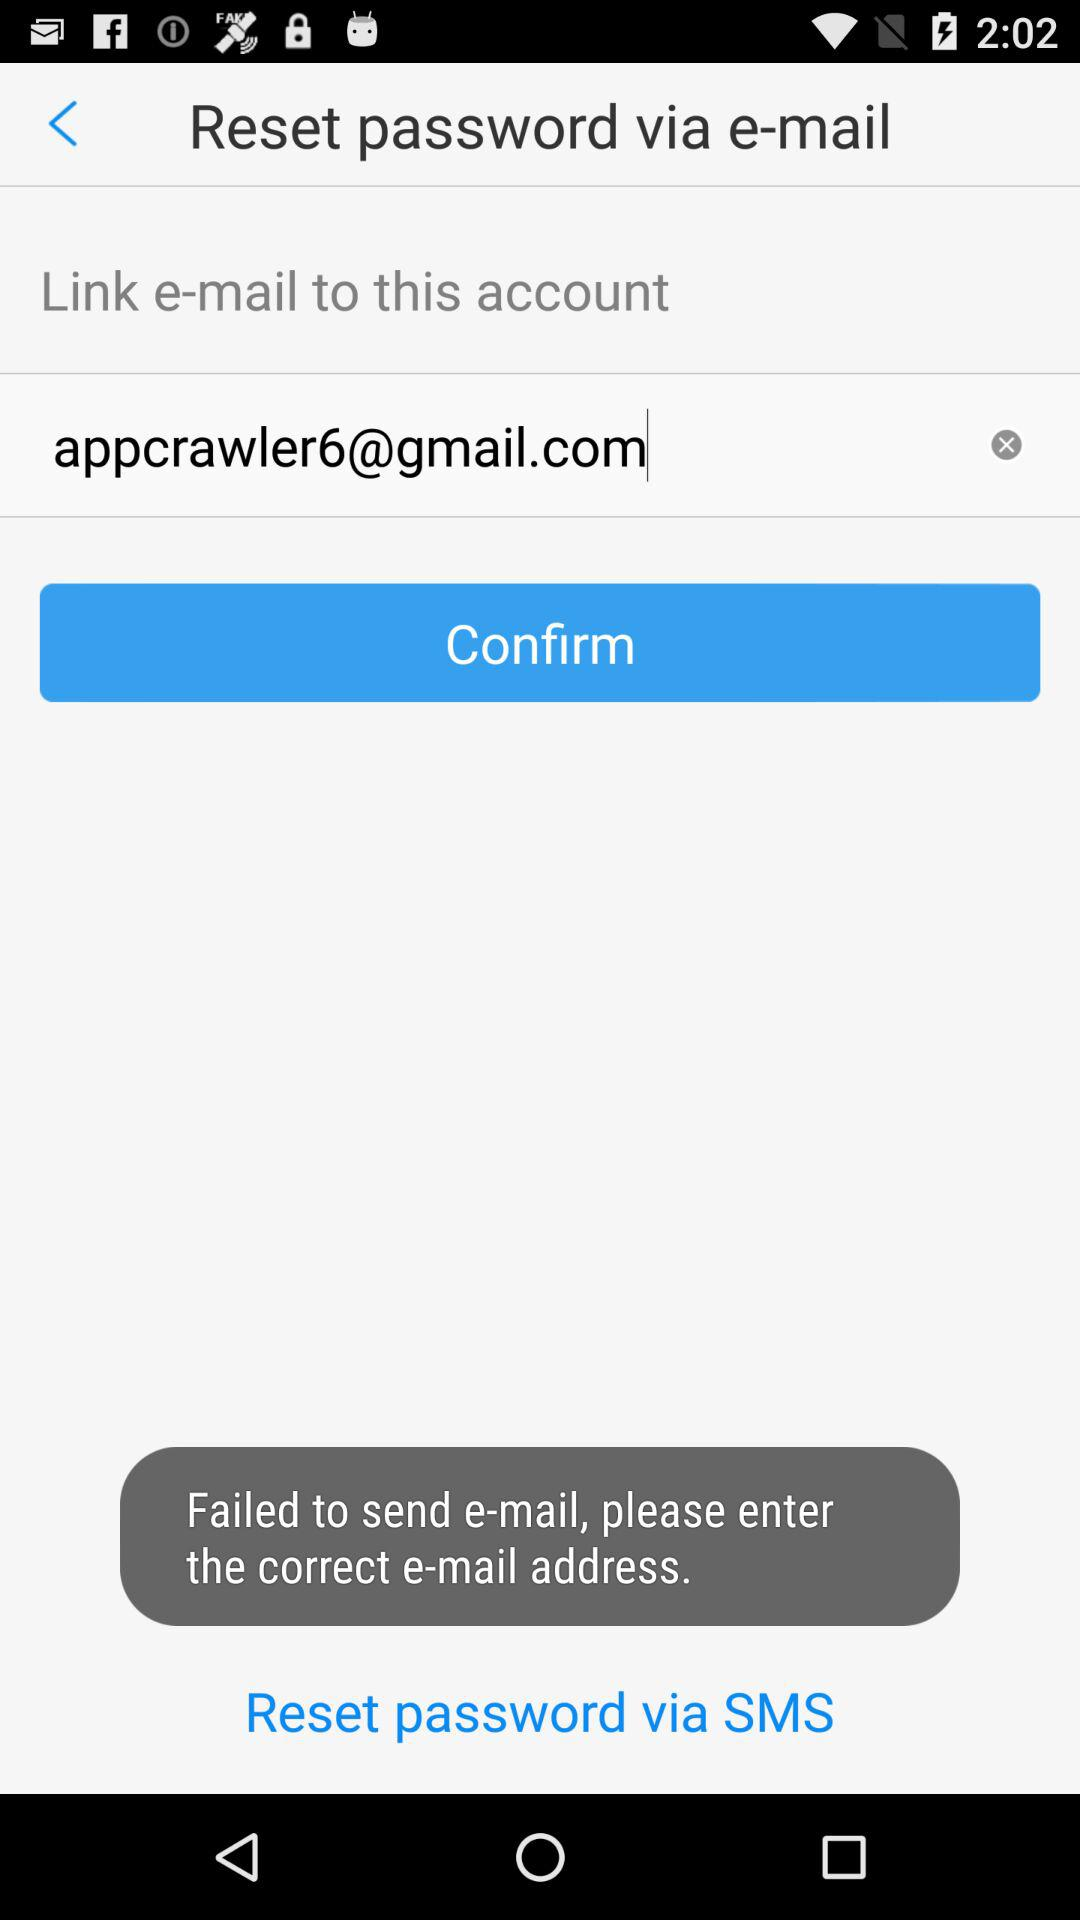What are the options to reset the password? The options are "e-mail" and "SMS". 